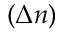Convert formula to latex. <formula><loc_0><loc_0><loc_500><loc_500>( \Delta n )</formula> 